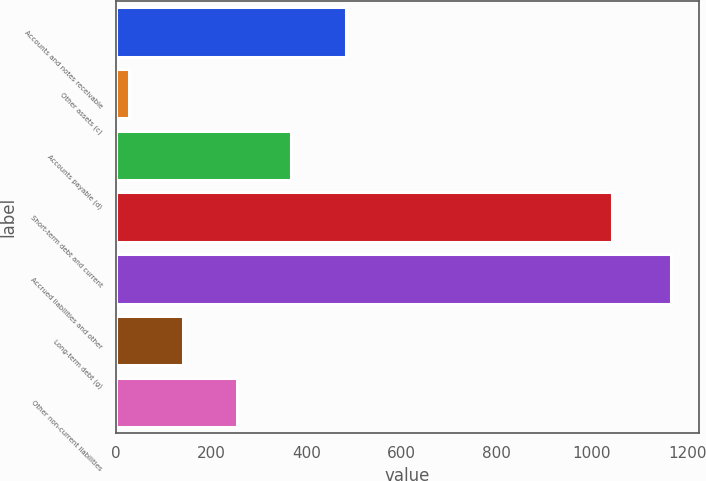Convert chart. <chart><loc_0><loc_0><loc_500><loc_500><bar_chart><fcel>Accounts and notes receivable<fcel>Other assets (c)<fcel>Accounts payable (d)<fcel>Short-term debt and current<fcel>Accrued liabilities and other<fcel>Long-term debt (g)<fcel>Other non-current liabilities<nl><fcel>482.4<fcel>26<fcel>368.3<fcel>1043<fcel>1167<fcel>140.1<fcel>254.2<nl></chart> 